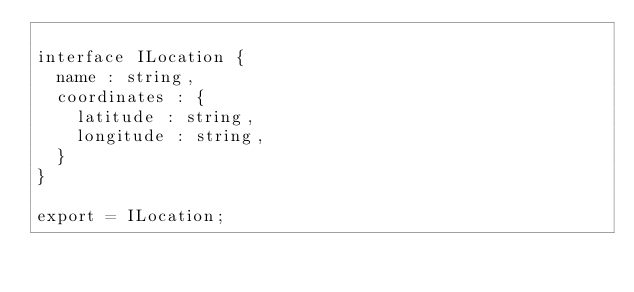Convert code to text. <code><loc_0><loc_0><loc_500><loc_500><_TypeScript_>
interface ILocation {
  name : string,
  coordinates : {
    latitude : string,
    longitude : string,
  }
}

export = ILocation;
</code> 